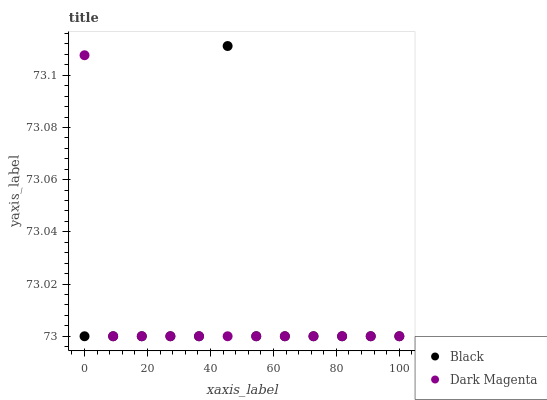Does Dark Magenta have the minimum area under the curve?
Answer yes or no. Yes. Does Black have the maximum area under the curve?
Answer yes or no. Yes. Does Dark Magenta have the maximum area under the curve?
Answer yes or no. No. Is Dark Magenta the smoothest?
Answer yes or no. Yes. Is Black the roughest?
Answer yes or no. Yes. Is Dark Magenta the roughest?
Answer yes or no. No. Does Black have the lowest value?
Answer yes or no. Yes. Does Black have the highest value?
Answer yes or no. Yes. Does Dark Magenta have the highest value?
Answer yes or no. No. Does Black intersect Dark Magenta?
Answer yes or no. Yes. Is Black less than Dark Magenta?
Answer yes or no. No. Is Black greater than Dark Magenta?
Answer yes or no. No. 